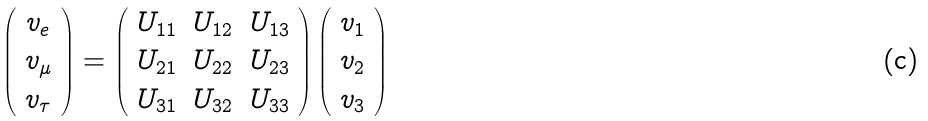Convert formula to latex. <formula><loc_0><loc_0><loc_500><loc_500>\left ( \begin{array} { c } v _ { e } \\ v _ { \mu } \\ v _ { \tau } \\ \end{array} \right ) = \left ( \begin{array} { c c c } U _ { 1 1 } & U _ { 1 2 } & U _ { 1 3 } \\ U _ { 2 1 } & U _ { 2 2 } & U _ { 2 3 } \\ U _ { 3 1 } & U _ { 3 2 } & U _ { 3 3 } \\ \end{array} \right ) \left ( \begin{array} { c } v _ { 1 } \\ v _ { 2 } \\ v _ { 3 } \\ \end{array} \right )</formula> 